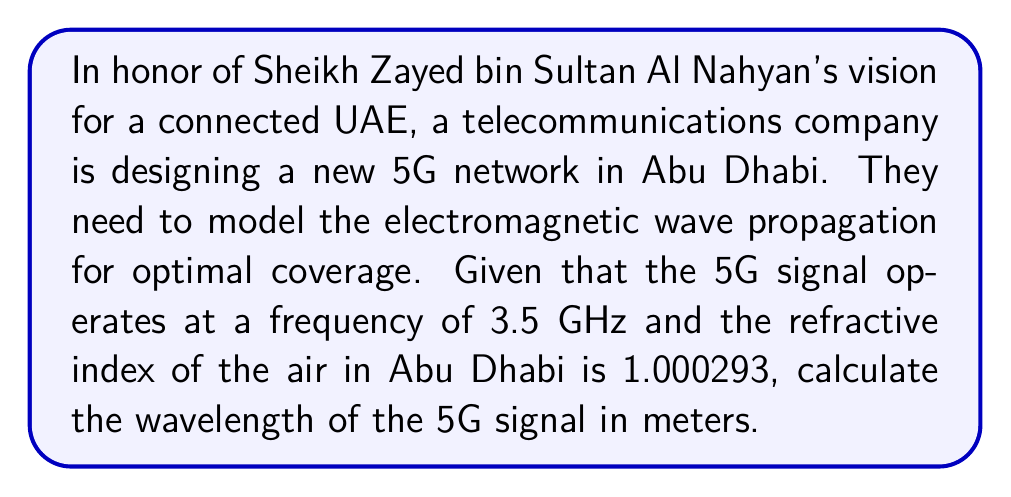Show me your answer to this math problem. To solve this problem, we'll follow these steps:

1) First, recall the relationship between the speed of light in vacuum ($c$), frequency ($f$), and wavelength ($\lambda$):

   $$c = f\lambda$$

2) The speed of light in a medium with refractive index $n$ is given by:

   $$v = \frac{c}{n}$$

3) Combining these equations, we get:

   $$\frac{c}{n} = f\lambda$$

4) Rearranging to solve for $\lambda$:

   $$\lambda = \frac{c}{nf}$$

5) Now, let's substitute the known values:
   - Speed of light in vacuum, $c = 2.99792458 \times 10^8$ m/s
   - Refractive index of air in Abu Dhabi, $n = 1.000293$
   - Frequency of 5G signal, $f = 3.5 \times 10^9$ Hz

6) Plugging these into our equation:

   $$\lambda = \frac{2.99792458 \times 10^8}{1.000293 \times 3.5 \times 10^9}$$

7) Calculating:

   $$\lambda \approx 0.0856 \text{ m}$$

8) Rounding to three significant figures:

   $$\lambda \approx 0.0856 \text{ m}$$
Answer: 0.0856 m 